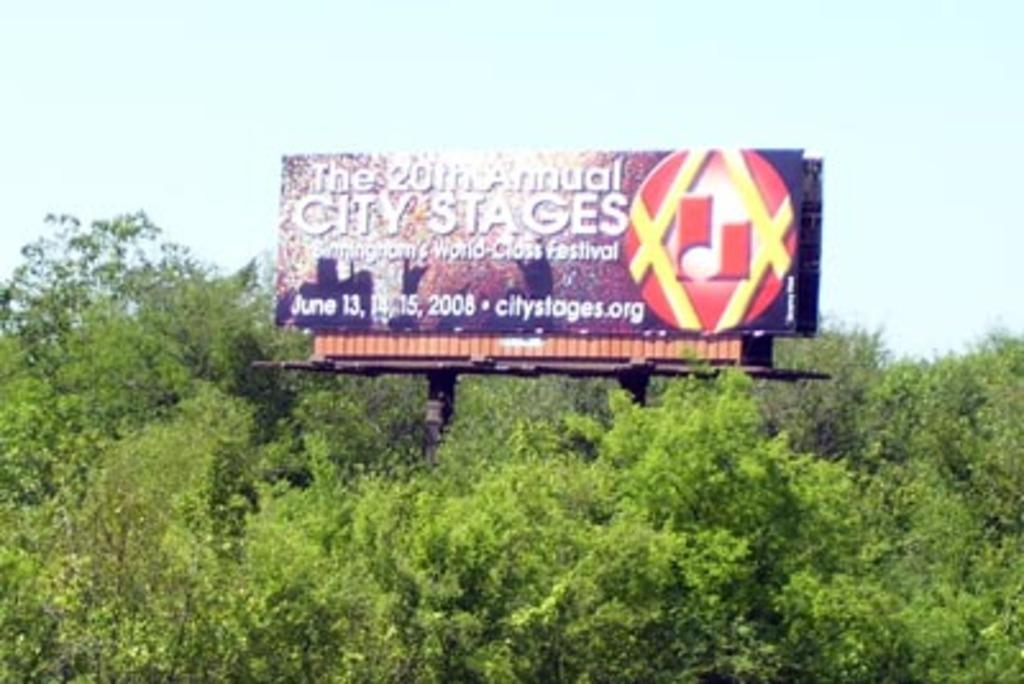<image>
Present a compact description of the photo's key features. A billboard for the 20th annual City Stages festival rises above the trees 